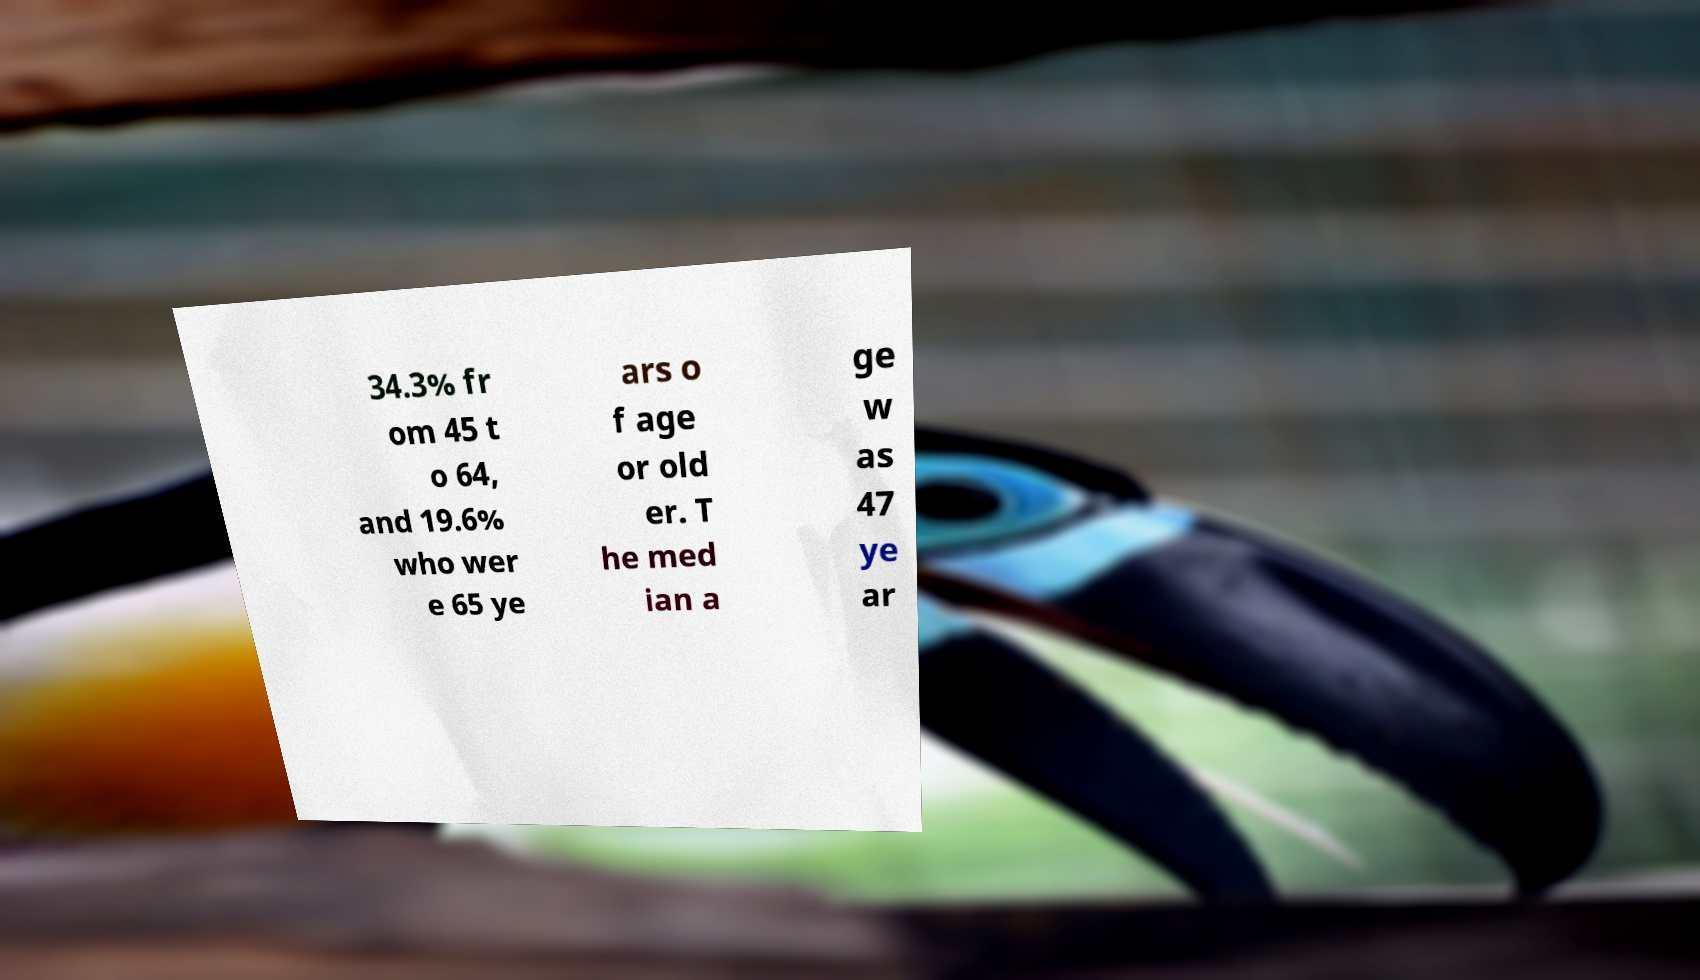I need the written content from this picture converted into text. Can you do that? 34.3% fr om 45 t o 64, and 19.6% who wer e 65 ye ars o f age or old er. T he med ian a ge w as 47 ye ar 